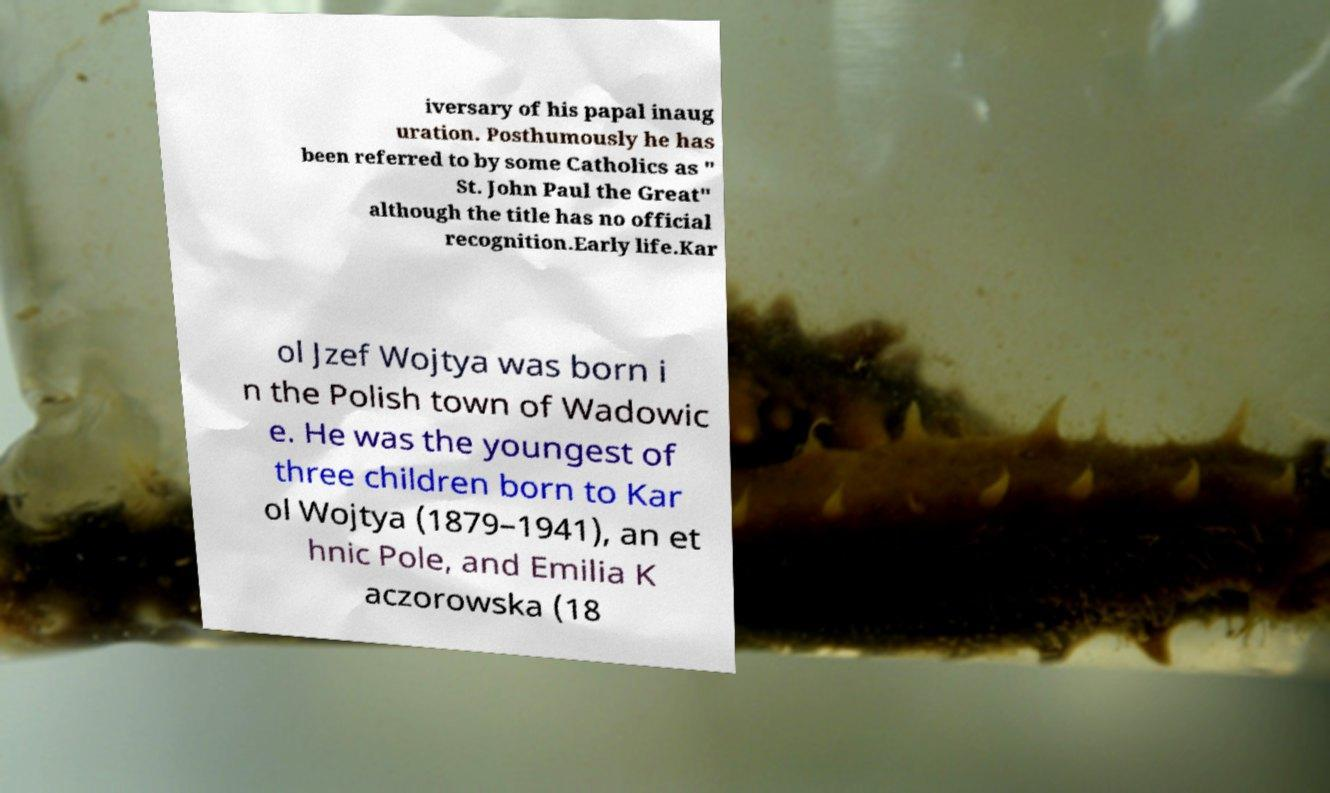What messages or text are displayed in this image? I need them in a readable, typed format. iversary of his papal inaug uration. Posthumously he has been referred to by some Catholics as " St. John Paul the Great" although the title has no official recognition.Early life.Kar ol Jzef Wojtya was born i n the Polish town of Wadowic e. He was the youngest of three children born to Kar ol Wojtya (1879–1941), an et hnic Pole, and Emilia K aczorowska (18 